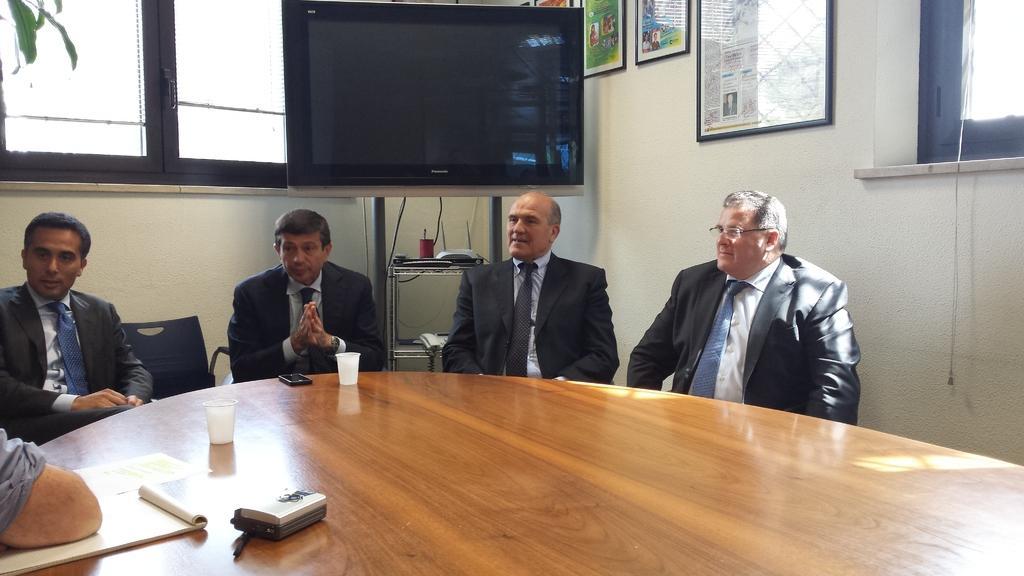Could you give a brief overview of what you see in this image? In this image there are four people who are sitting on a chair in front of them there is one table on that table there are tea cups and one book and one mobile is there and in the middle there is one television and on the left side there is one window and on the right side there is wall and on that wall there are some photo frames and on the top of the right corner there is one window. 